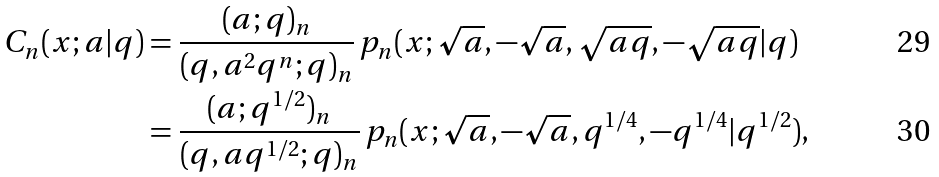<formula> <loc_0><loc_0><loc_500><loc_500>C _ { n } ( x ; a | q ) & = \frac { ( a ; q ) _ { n } } { ( q , a ^ { 2 } q ^ { n } ; q ) _ { n } } \, p _ { n } ( x ; \sqrt { a } , - \sqrt { a } , \sqrt { a q } , - \sqrt { a q } | q ) \\ & = \frac { ( a ; q ^ { 1 / 2 } ) _ { n } } { ( q , a q ^ { 1 / 2 } ; q ) _ { n } } \, p _ { n } ( x ; \sqrt { a } , - \sqrt { a } , q ^ { 1 / 4 } , - q ^ { 1 / 4 } | q ^ { 1 / 2 } ) ,</formula> 